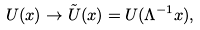<formula> <loc_0><loc_0><loc_500><loc_500>U ( x ) \rightarrow \tilde { U } ( x ) = U ( \Lambda ^ { - 1 } x ) ,</formula> 